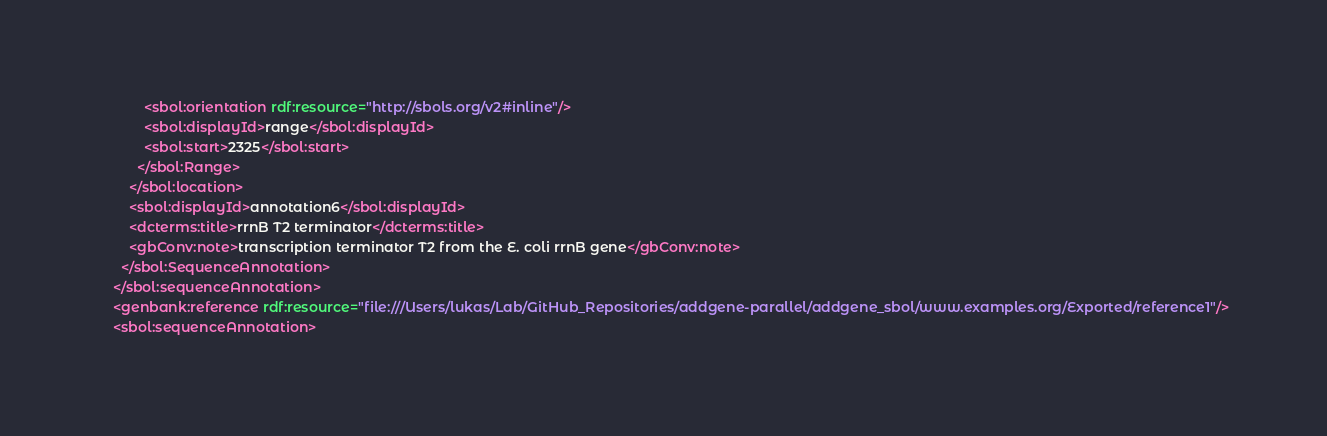Convert code to text. <code><loc_0><loc_0><loc_500><loc_500><_XML_>            <sbol:orientation rdf:resource="http://sbols.org/v2#inline"/>
            <sbol:displayId>range</sbol:displayId>
            <sbol:start>2325</sbol:start>
          </sbol:Range>
        </sbol:location>
        <sbol:displayId>annotation6</sbol:displayId>
        <dcterms:title>rrnB T2 terminator</dcterms:title>
        <gbConv:note>transcription terminator T2 from the E. coli rrnB gene</gbConv:note>
      </sbol:SequenceAnnotation>
    </sbol:sequenceAnnotation>
    <genbank:reference rdf:resource="file:///Users/lukas/Lab/GitHub_Repositories/addgene-parallel/addgene_sbol/www.examples.org/Exported/reference1"/>
    <sbol:sequenceAnnotation></code> 